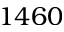Convert formula to latex. <formula><loc_0><loc_0><loc_500><loc_500>1 4 6 0</formula> 